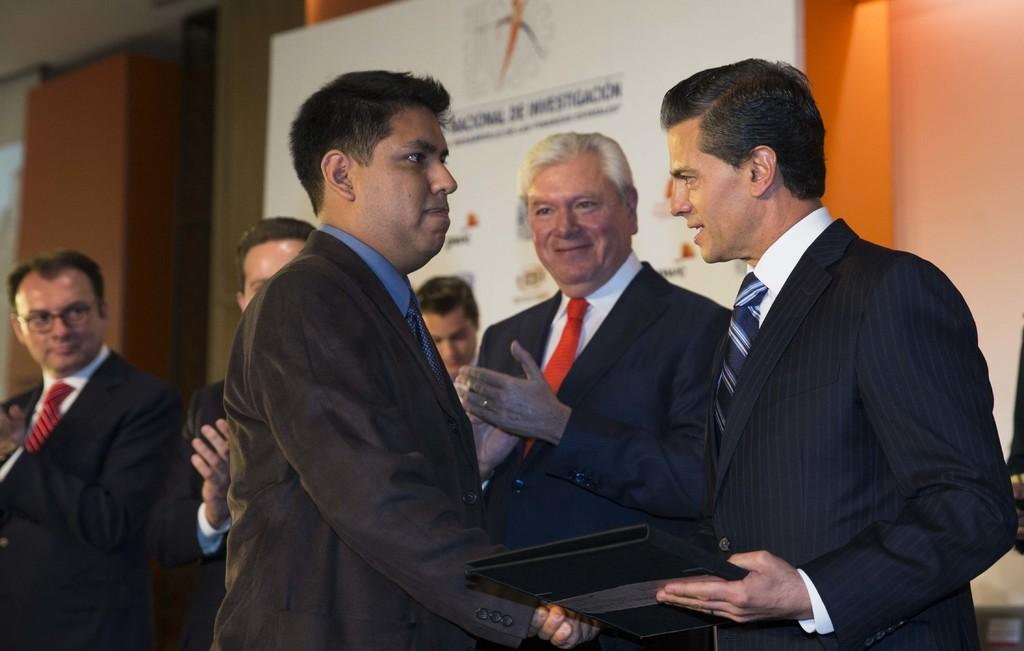What is the person holding in the image? The person is holding a cup of coffee. What else can be seen in the image besides the person and the cup of coffee? There is a table with some objects on it. What is visible in the background of the image? There is a window and a plant in the background of the image. What type of fiction is the person reading in the image? There is no book or reading material present in the image, so it is not possible to determine what type of fiction the person might be reading. 